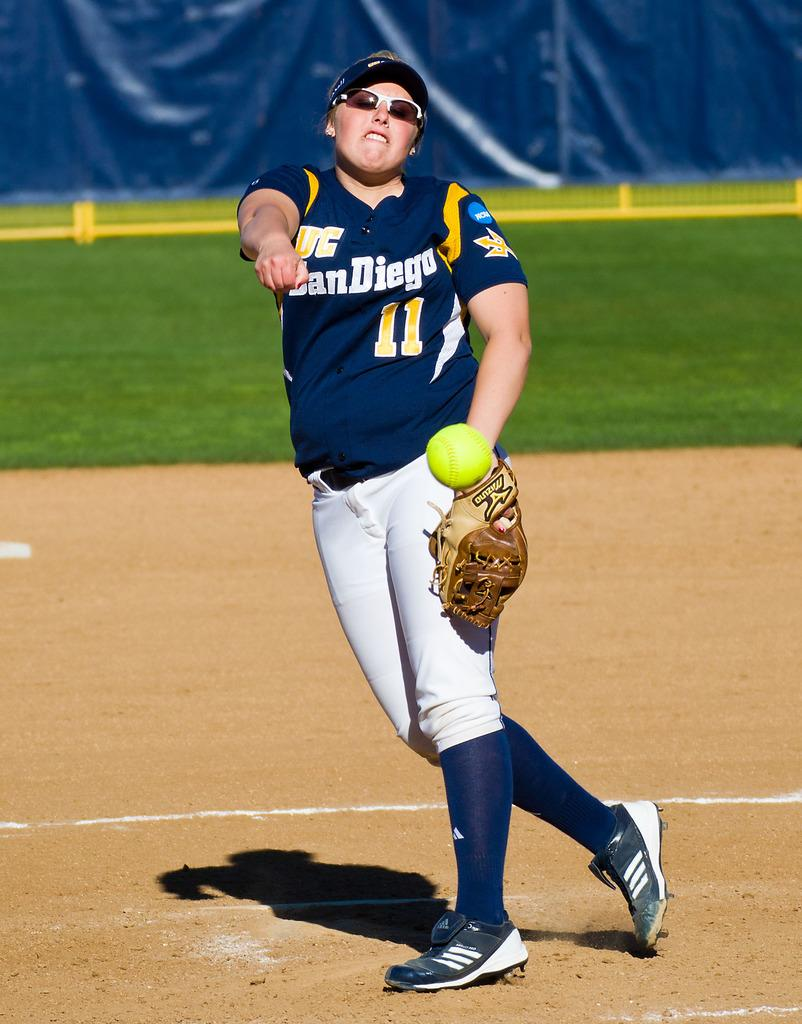<image>
Offer a succinct explanation of the picture presented. A softball player from a San Diego team throws a ball. 